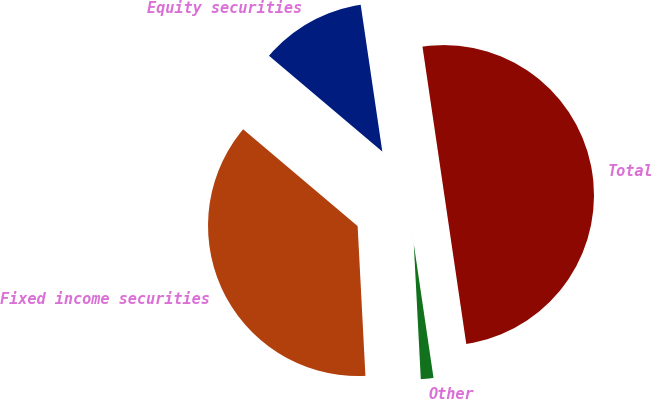<chart> <loc_0><loc_0><loc_500><loc_500><pie_chart><fcel>Equity securities<fcel>Fixed income securities<fcel>Other<fcel>Total<nl><fcel>11.5%<fcel>37.0%<fcel>1.5%<fcel>50.0%<nl></chart> 